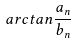Convert formula to latex. <formula><loc_0><loc_0><loc_500><loc_500>a r c t a n \frac { a _ { n } } { b _ { n } }</formula> 